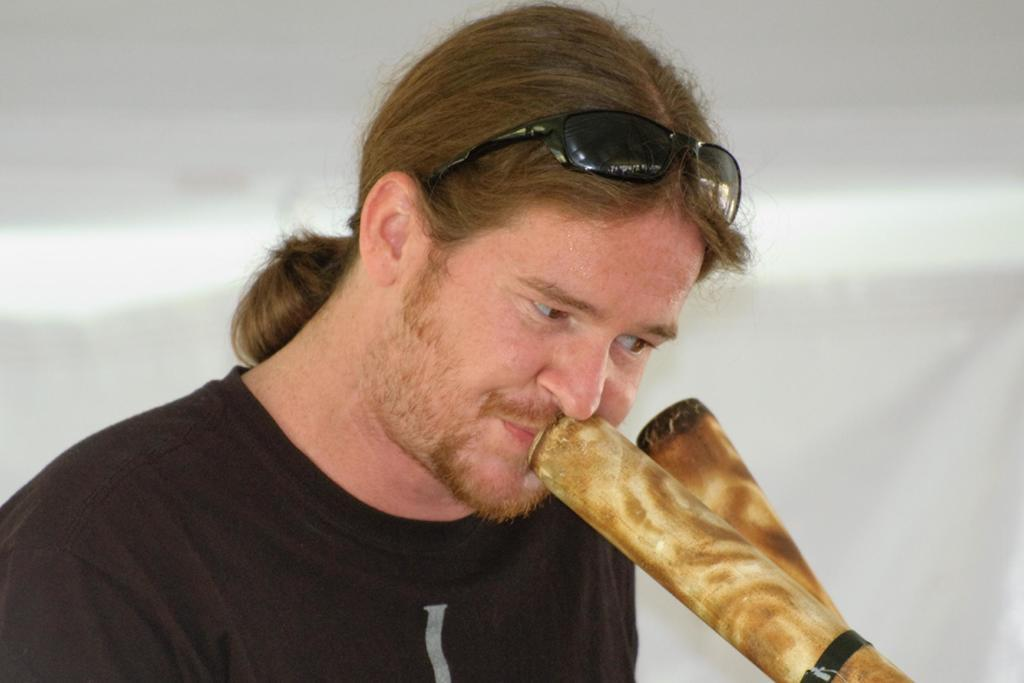Who is the main subject in the image? There is a man in the image. What objects are in front of the man? There are two bamboo sticks in front of the man. What protective gear is the man wearing? The man is wearing goggles. Can you describe the background of the image? The background of the image is blurry. How many sisters does the man have in the image? There is no information about the man's sisters in the image. What type of sugar is being used in the image? There is no sugar present in the image. 